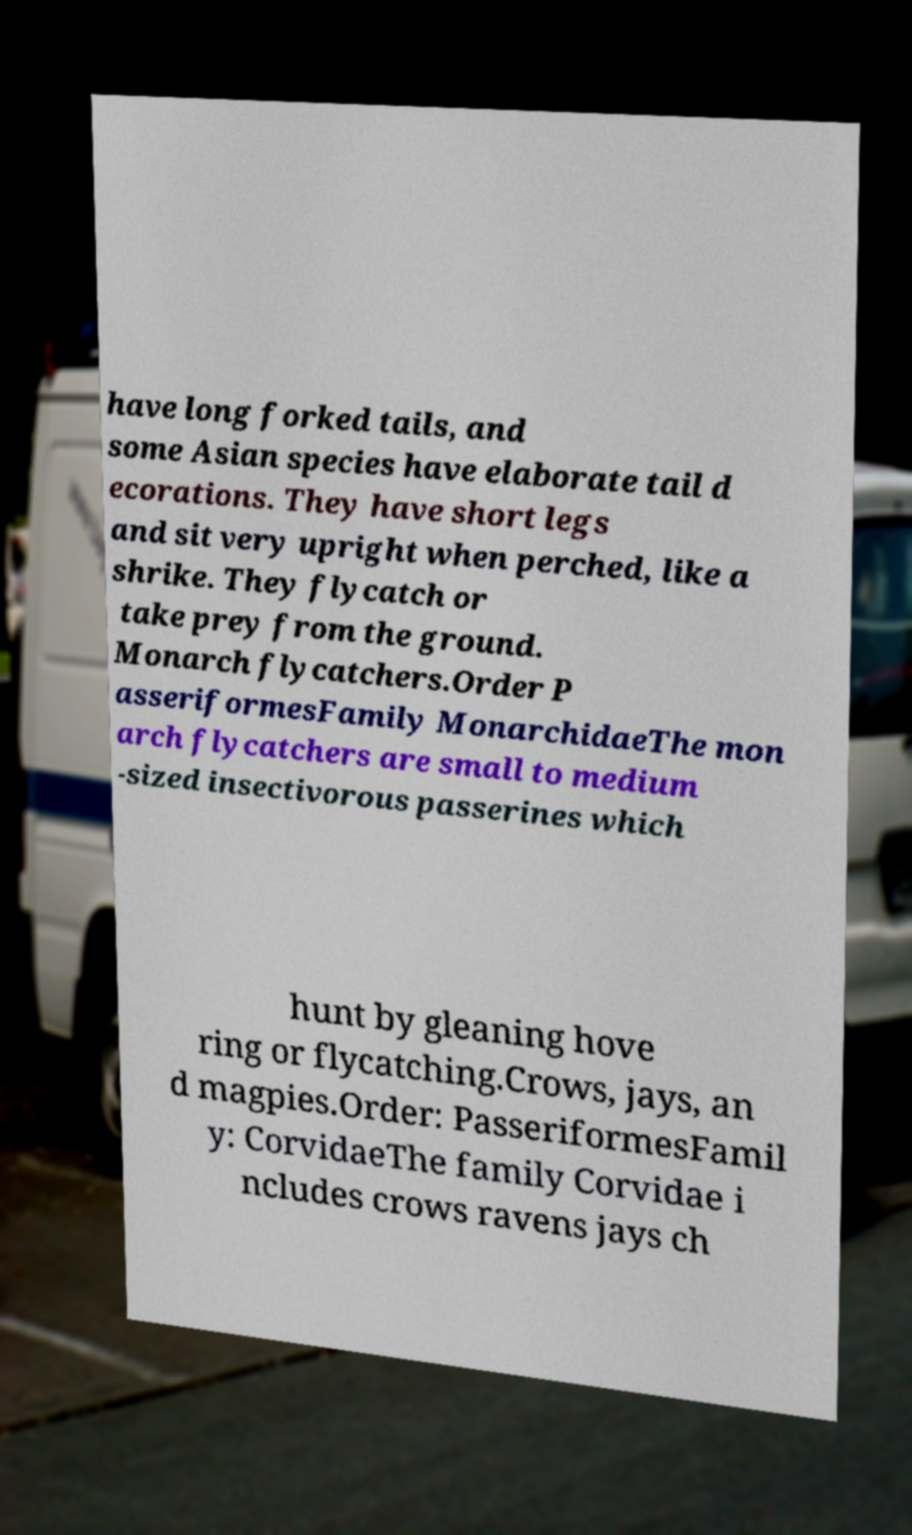Can you read and provide the text displayed in the image?This photo seems to have some interesting text. Can you extract and type it out for me? have long forked tails, and some Asian species have elaborate tail d ecorations. They have short legs and sit very upright when perched, like a shrike. They flycatch or take prey from the ground. Monarch flycatchers.Order P asseriformesFamily MonarchidaeThe mon arch flycatchers are small to medium -sized insectivorous passerines which hunt by gleaning hove ring or flycatching.Crows, jays, an d magpies.Order: PasseriformesFamil y: CorvidaeThe family Corvidae i ncludes crows ravens jays ch 